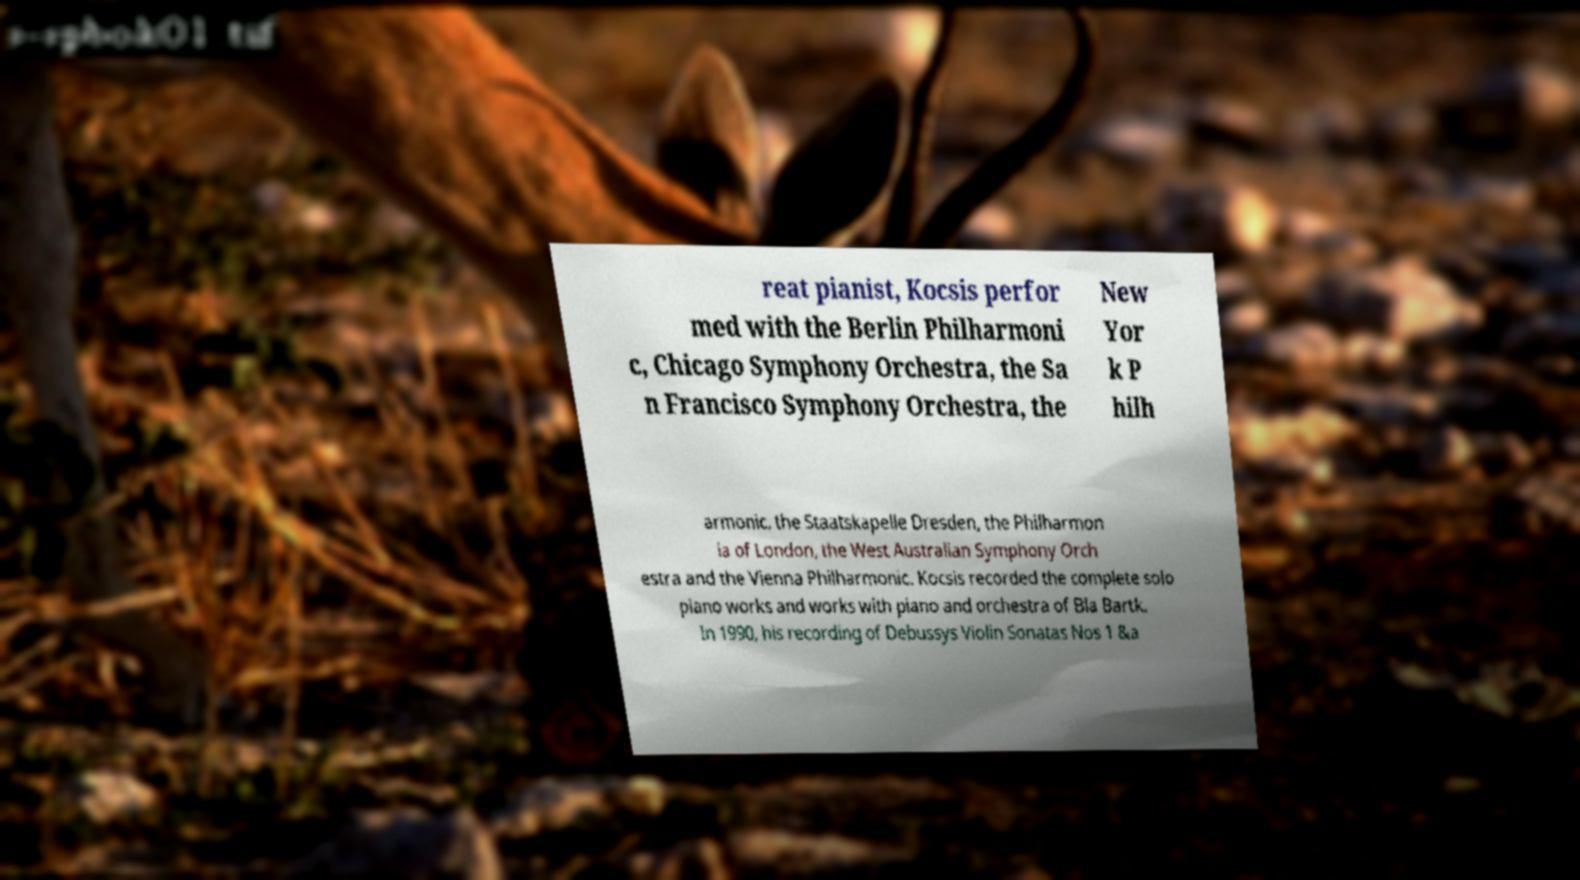There's text embedded in this image that I need extracted. Can you transcribe it verbatim? reat pianist, Kocsis perfor med with the Berlin Philharmoni c, Chicago Symphony Orchestra, the Sa n Francisco Symphony Orchestra, the New Yor k P hilh armonic, the Staatskapelle Dresden, the Philharmon ia of London, the West Australian Symphony Orch estra and the Vienna Philharmonic. Kocsis recorded the complete solo piano works and works with piano and orchestra of Bla Bartk. In 1990, his recording of Debussys Violin Sonatas Nos 1 &a 